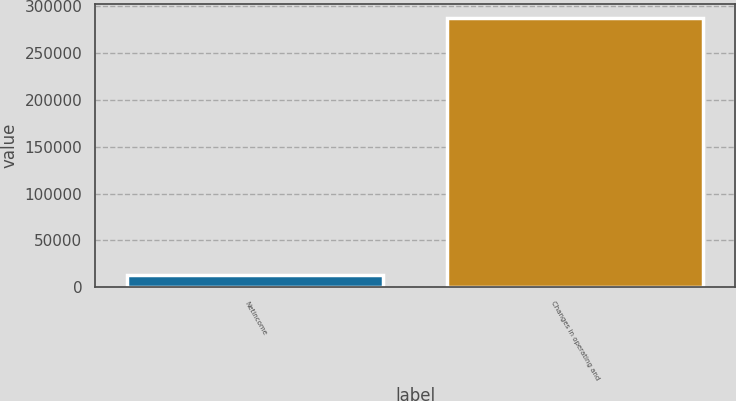Convert chart to OTSL. <chart><loc_0><loc_0><loc_500><loc_500><bar_chart><fcel>Netincome<fcel>Changes in operating and<nl><fcel>13485<fcel>287599<nl></chart> 